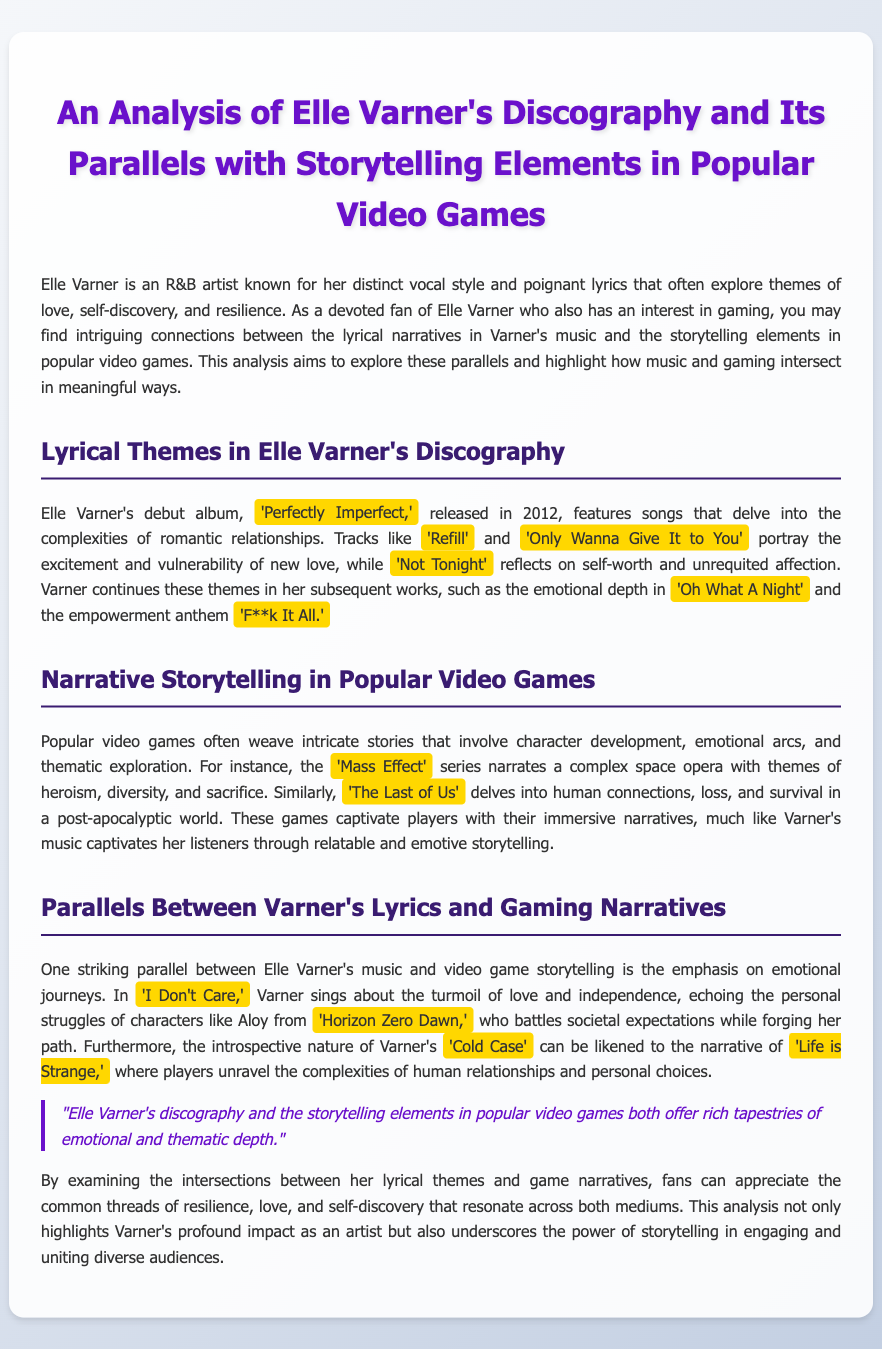What is the name of Elle Varner's debut album? The name of Elle Varner's debut album is mentioned as 'Perfectly Imperfect.'
Answer: 'Perfectly Imperfect' In what year was 'Perfectly Imperfect' released? The release year of Elle Varner's debut album is stated in the document.
Answer: 2012 Which song reflects on self-worth and unrequited affection? The song described as reflecting on self-worth and unrequited affection is 'Not Tonight.'
Answer: 'Not Tonight' What video game series is mentioned that narrates a complex space opera? The document refers to the 'Mass Effect' series as narrating a complex space opera.
Answer: 'Mass Effect' Which character is compared to Elle Varner's song 'I Don't Care'? The character compared in the document is Aloy from 'Horizon Zero Dawn.'
Answer: Aloy What is a central theme in the analysis of both Elle Varner's music and popular video games? A central theme highlighted in the analysis is resilience, love, and self-discovery.
Answer: resilience, love, and self-discovery Which song showcases the emotional depth in Varner's work? The song noted for showcasing emotional depth is 'Oh What A Night.'
Answer: 'Oh What A Night' What does the document highlight about the impact of Elle Varner as an artist? The document states that it underscores the power of storytelling in engaging and uniting diverse audiences regarding Varner's impact.
Answer: profound impact What is the document's primary focus? The primary focus of the document is the analysis of Elle Varner's discography and its parallels with storytelling elements in popular video games.
Answer: analysis of Elle Varner's discography 